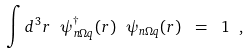<formula> <loc_0><loc_0><loc_500><loc_500>\int d ^ { 3 } r \ \psi ^ { \dagger } _ { n \Omega q } ( { r } ) \ \psi _ { n \Omega q } ( { r } ) \ = \ 1 \ ,</formula> 